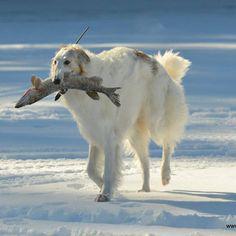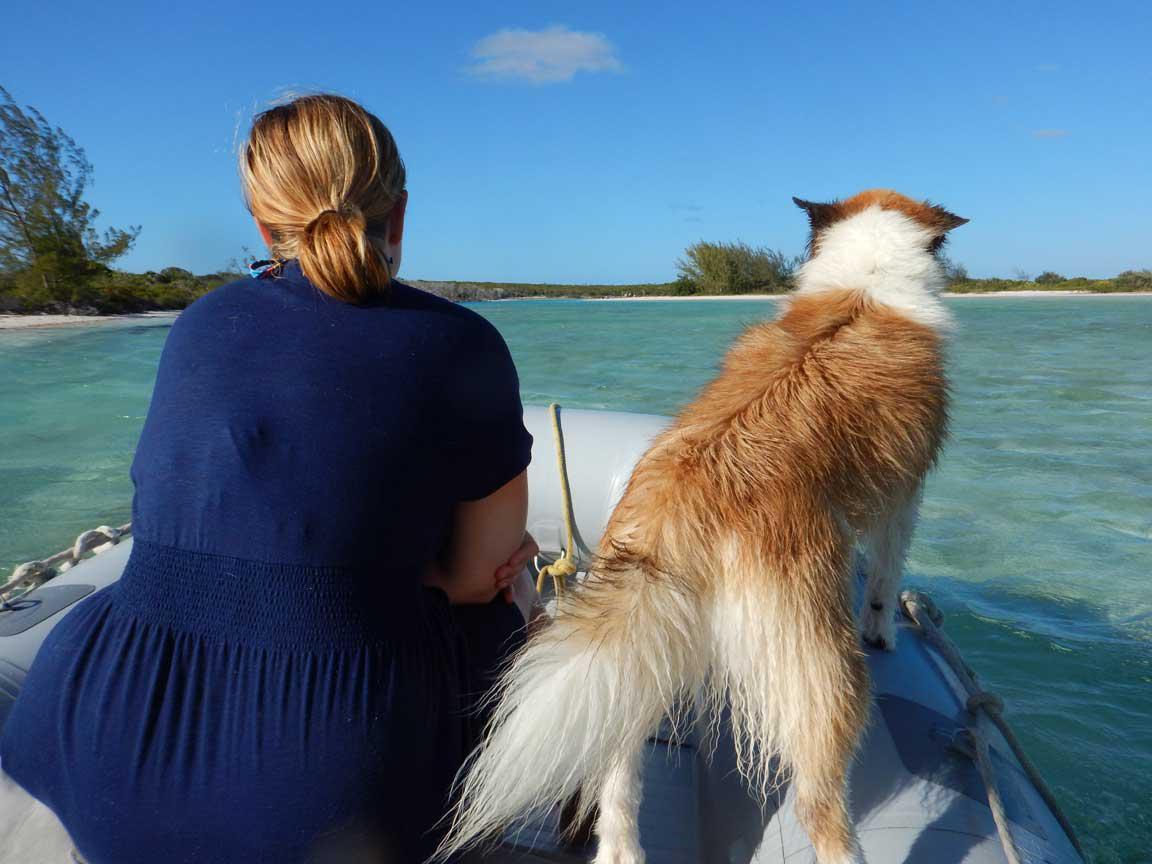The first image is the image on the left, the second image is the image on the right. Assess this claim about the two images: "An image contains at least one dog inside an inflatable flotation device.". Correct or not? Answer yes or no. Yes. The first image is the image on the left, the second image is the image on the right. Examine the images to the left and right. Is the description "One image shows at least one hound in a raft on water, and the other image shows a hound that is upright and trotting." accurate? Answer yes or no. Yes. 